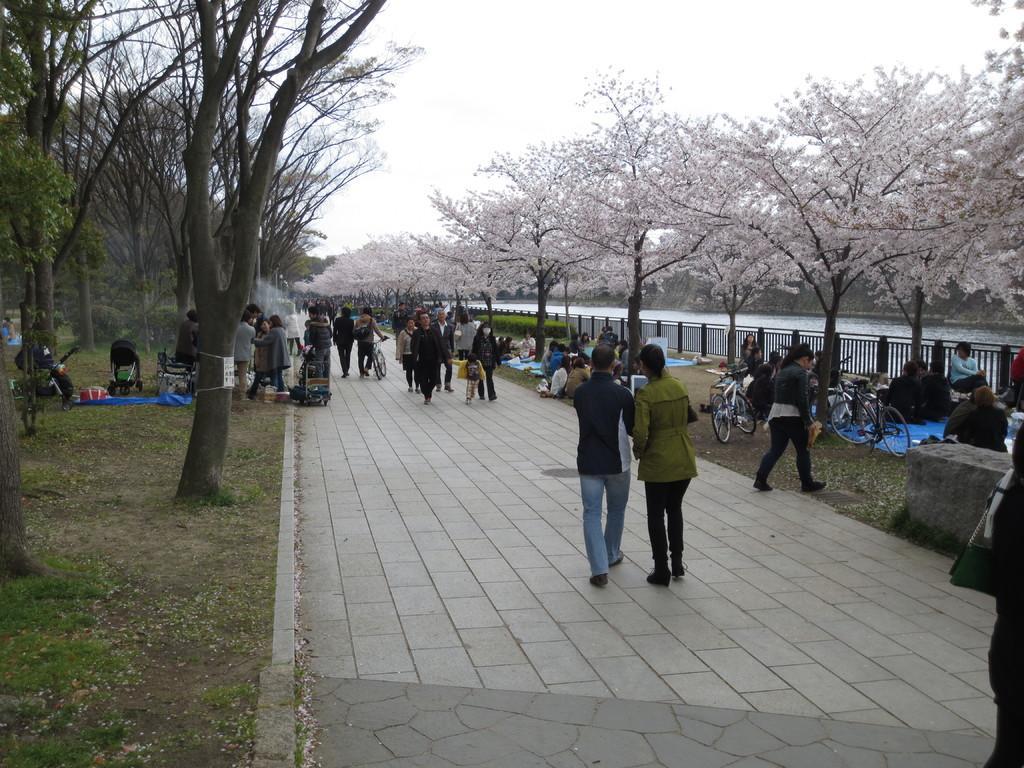Can you describe this image briefly? In this image, we can see trees, plants, grass, few people, bicycles and vehicles. Here in the middle of the image, few people are walking through the walkway. Background we can see railings, water and sky. 